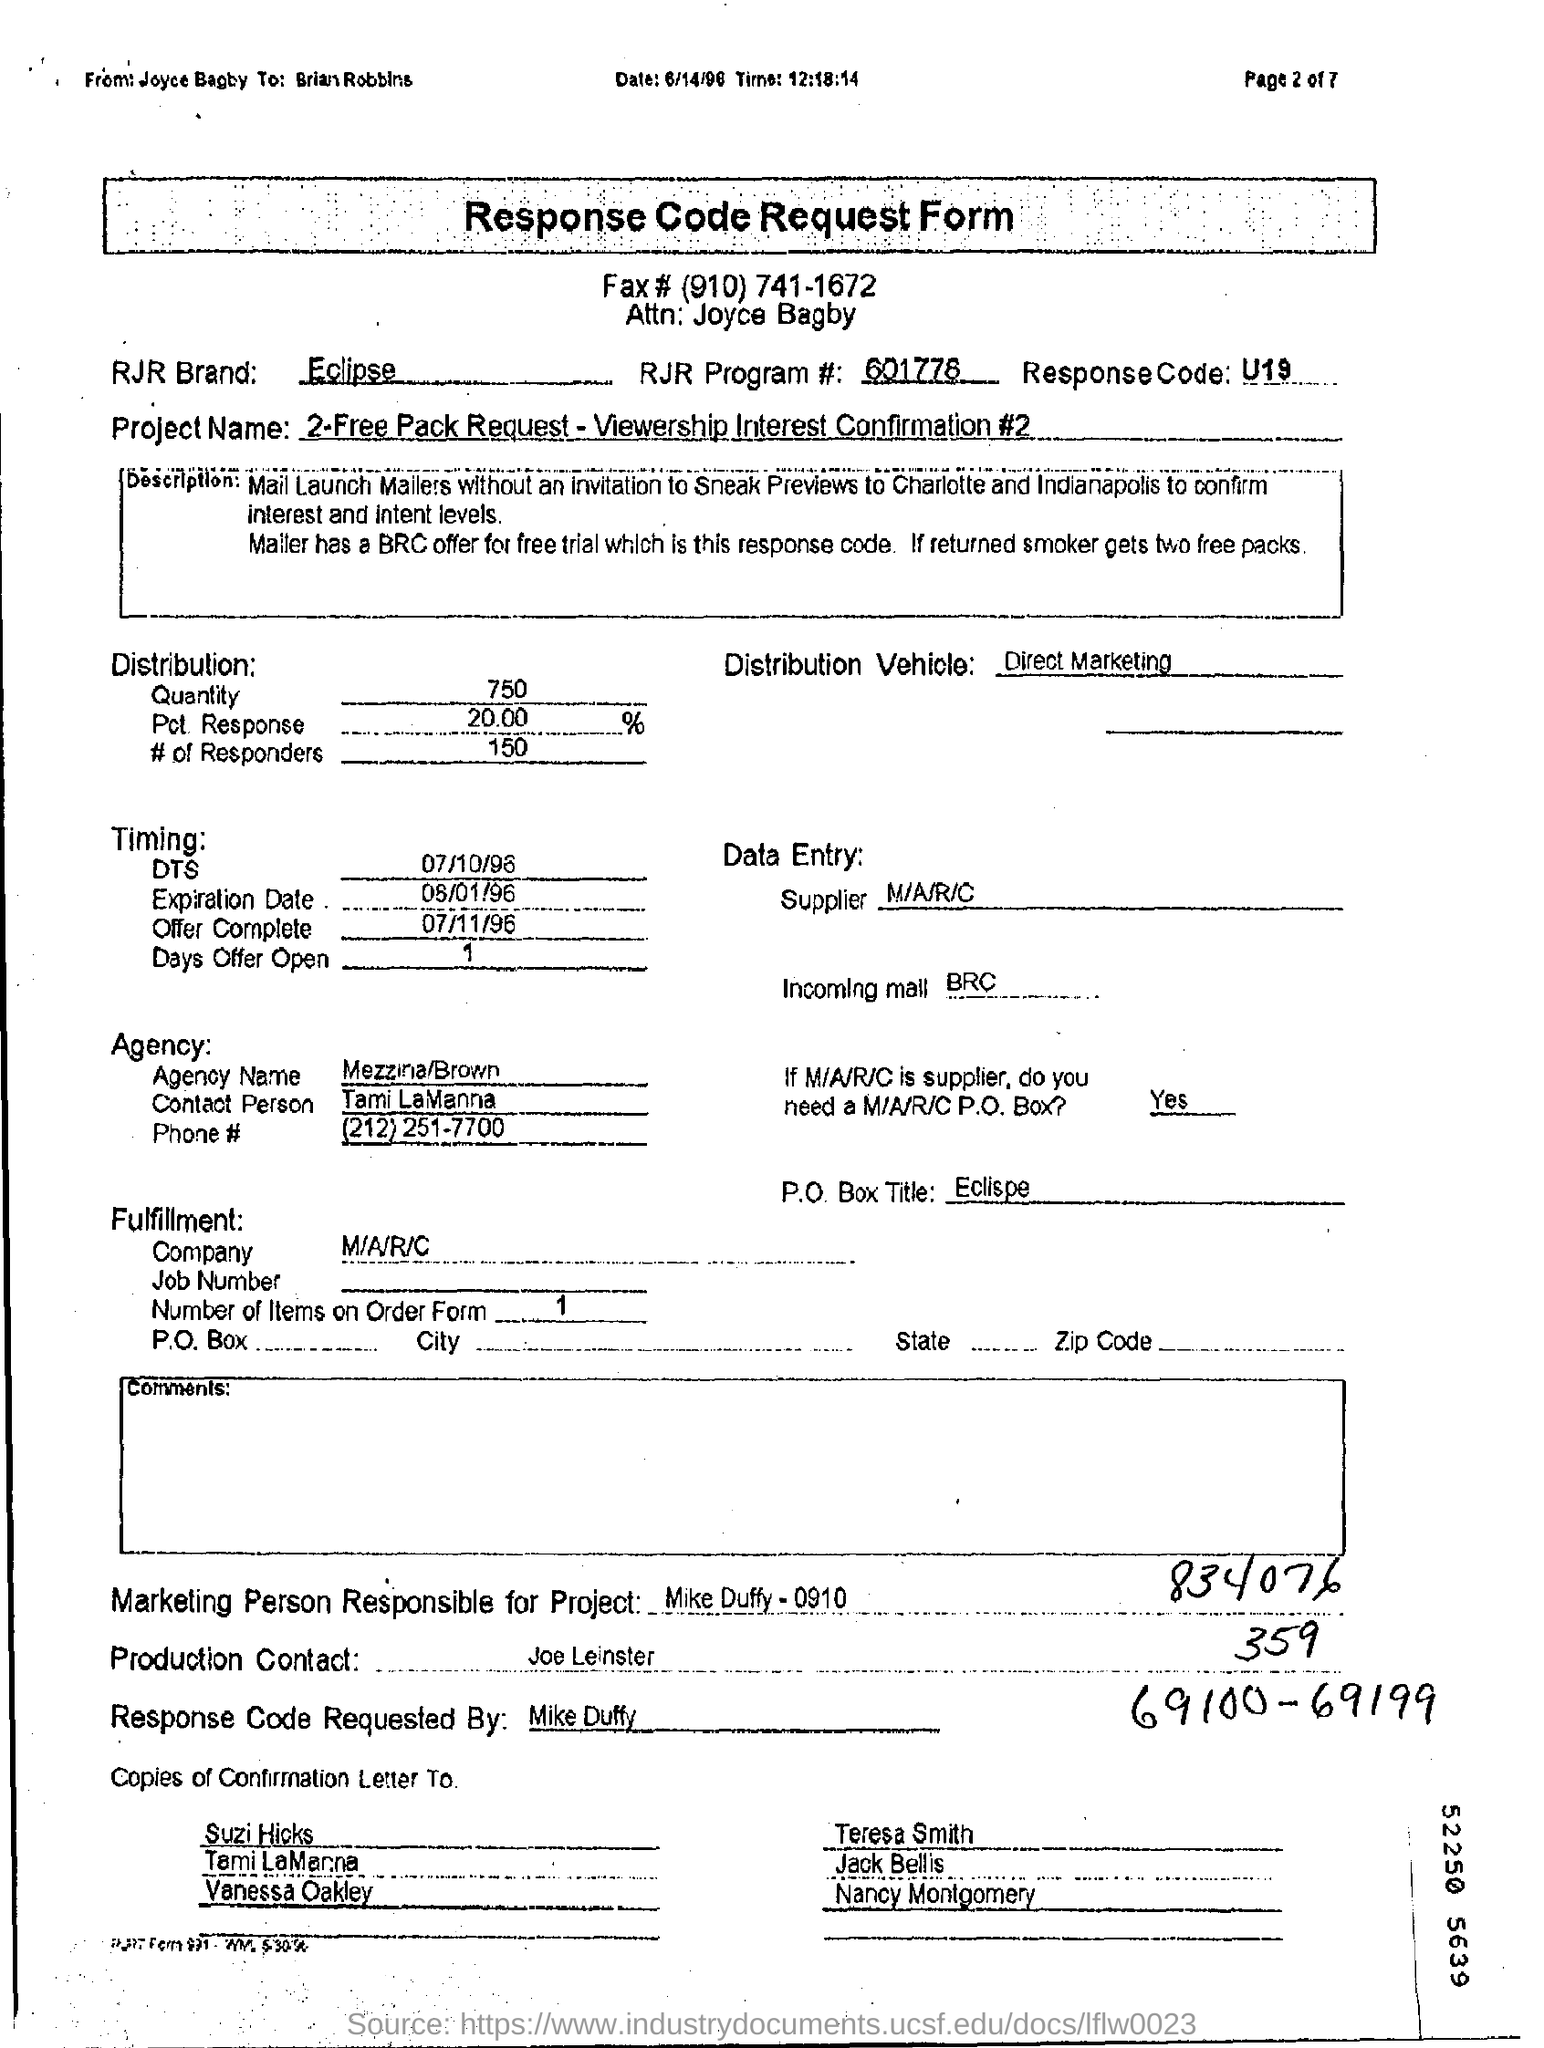Give some essential details in this illustration. The name of the RJR Brand is Eclipse. The name of the agency is Mezzina/Brown. The name of the person for production contact is Joe Leinster. The response code is U19, indicating an error or unexpected result. The RJR program code is #601778... 